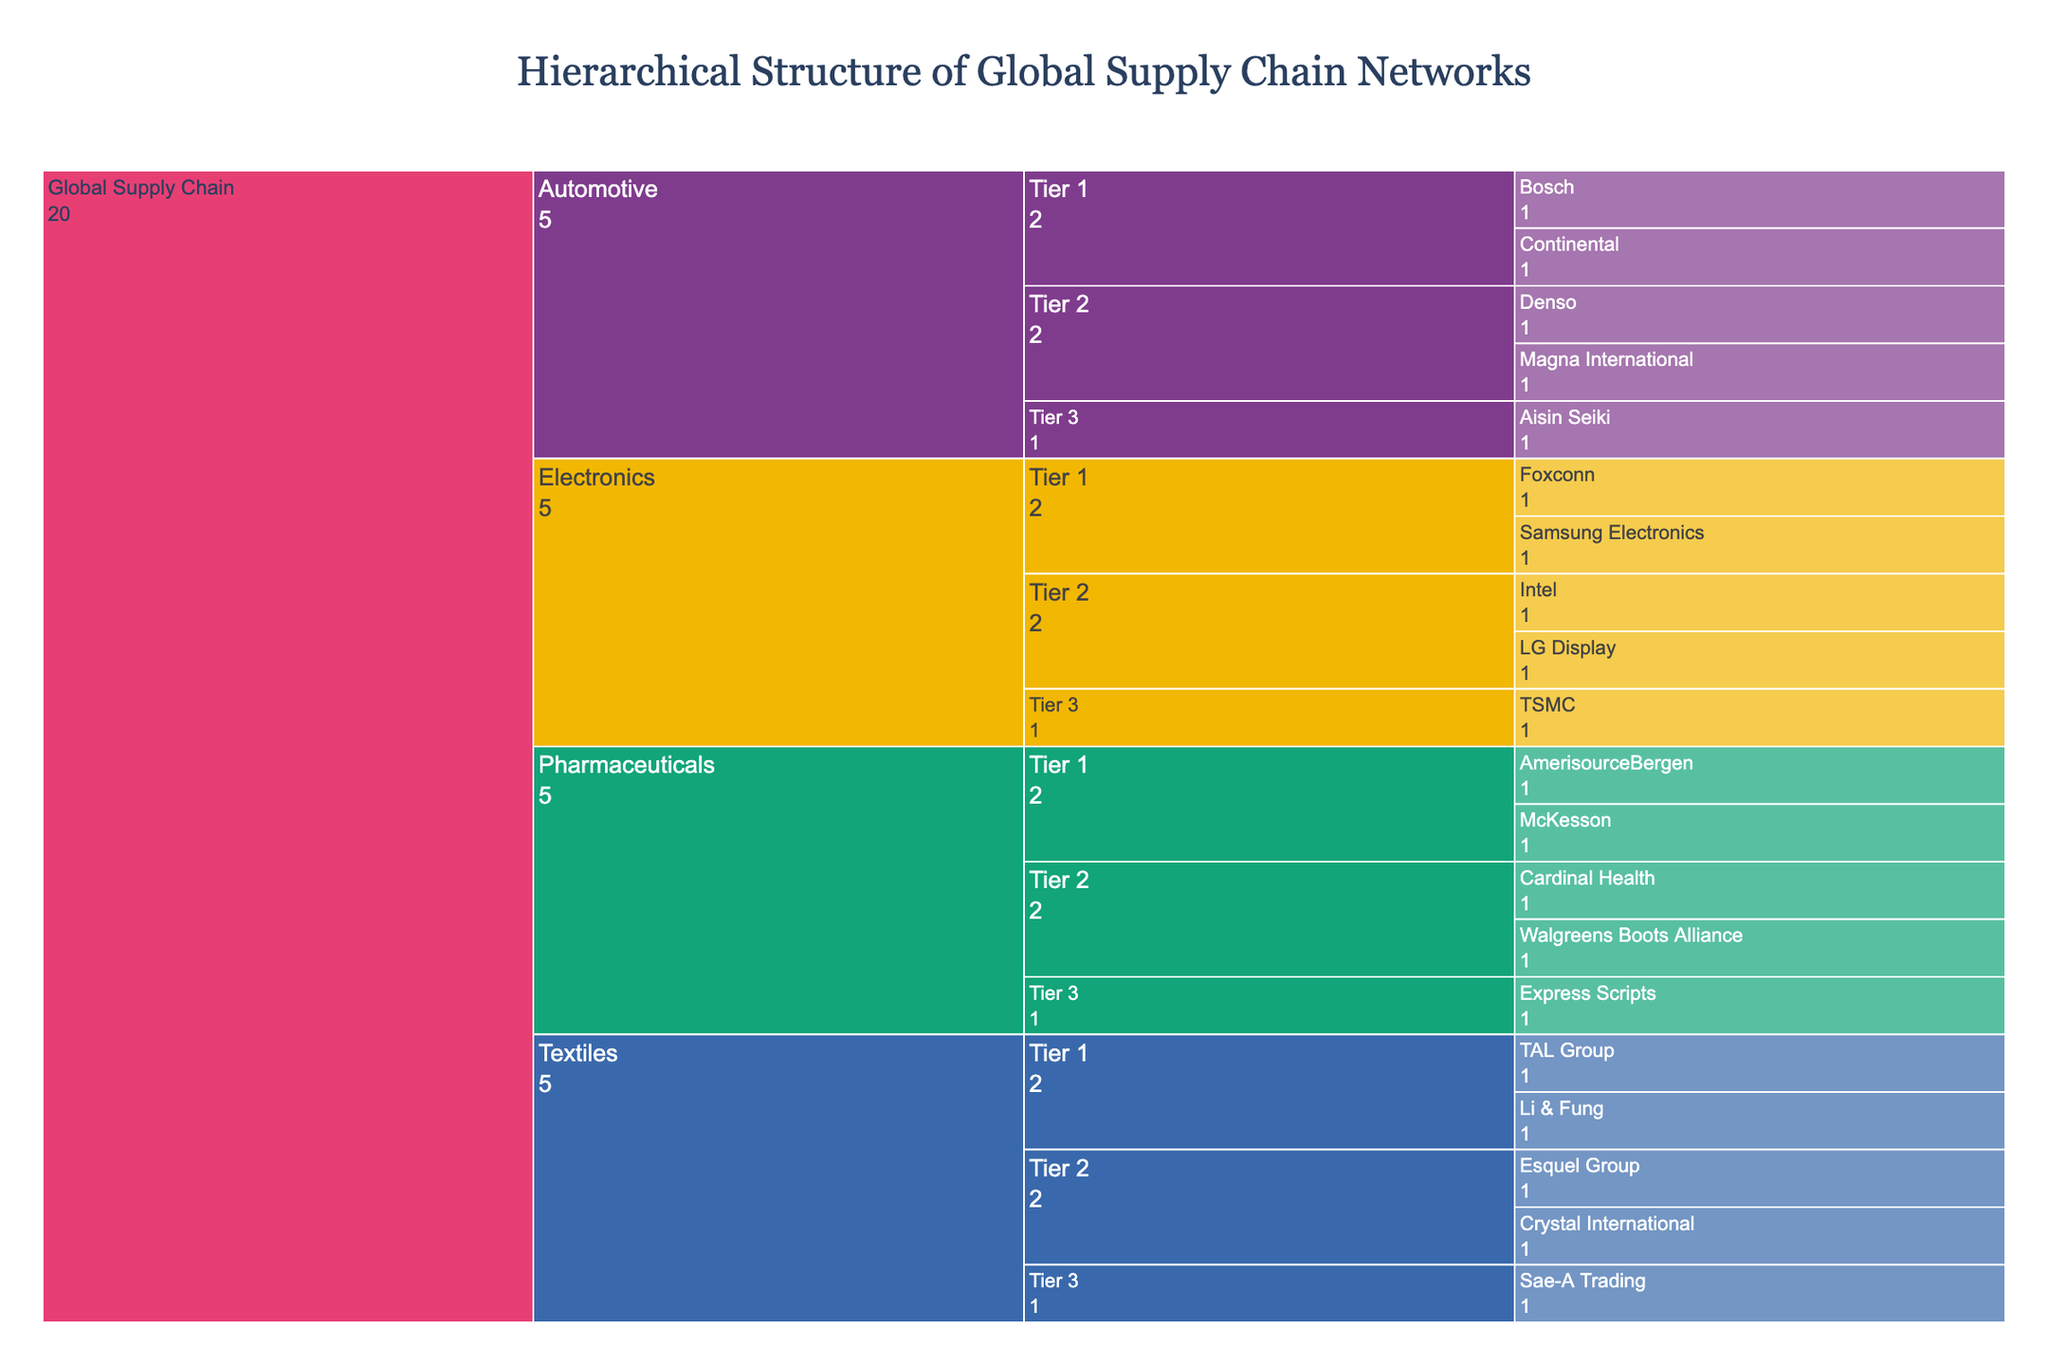What is the title of the chart? The title of the chart is prominently displayed at the top and reads "Hierarchical Structure of Global Supply Chain Networks".
Answer: Hierarchical Structure of Global Supply Chain Networks What industries are represented in the global supply chain according to the chart? The icicle chart visualizes different industries in the global supply chain by their labels. The industries shown are Automotive, Electronics, Textiles, and Pharmaceuticals.
Answer: Automotive, Electronics, Textiles, Pharmaceuticals How many companies are in Tier 1 of the Electronics industry? By examining the branches of the Electronics industry at Tier 1, we see that there are two companies: Foxconn and Samsung Electronics.
Answer: 2 In which industry is Aisin Seiki, and what tier? By following the hierarchy of the chart in the Automotive industry, Aisin Seiki is placed under Tier 3.
Answer: Automotive, Tier 3 Which tier has the most companies in the Textiles industry? The Textiles industry is divided into tiers and by counting the companies in each tier, Tier 2 has more companies (Esquel Group and Crystal International) compared to Tier 1 and Tier 3.
Answer: Tier 2 What is the total number of companies listed under the Pharmaceuticals industry? By adding the number of companies across the three tiers of the Pharmaceuticals industry: Tier 1 has McKesson and AmerisourceBergen, Tier 2 has Cardinal Health and Walgreens Boots Alliance, Tier 3 has Express Scripts. Thus, there are 5 companies in total.
Answer: 5 Compare the number of companies in Tier 2 between the Automotive and Pharmaceuticals industries. Which one has more? For the Automotive industry in Tier 2, there are Magna International and Denso, totaling 2 companies. For Pharmaceuticals, Tier 2 includes Cardinal Health and Walgreens Boots Alliance, also totaling 2 companies. Therefore, they have an equal number of companies at Tier 2.
Answer: Equal How many tiers are represented within each industry in the chart? Each industry (Automotive, Electronics, Textiles, and Pharmaceuticals) is divided into three tiers, as indicated by the chart hierarchy and labels.
Answer: 3 Which industry has the company with the name starting with "S"? By scanning through the company names across the industries, companies starting with "S" are Samsung Electronics in Electronics, and Sae-A Trading in Textiles.
Answer: Electronics, Textiles Identify the company in the Textiles industry, Tier 1. In Tier 1 of the Textiles industry branch, we find that the companies listed are Li & Fung and the TAL Group.
Answer: Li & Fung, TAL Group 